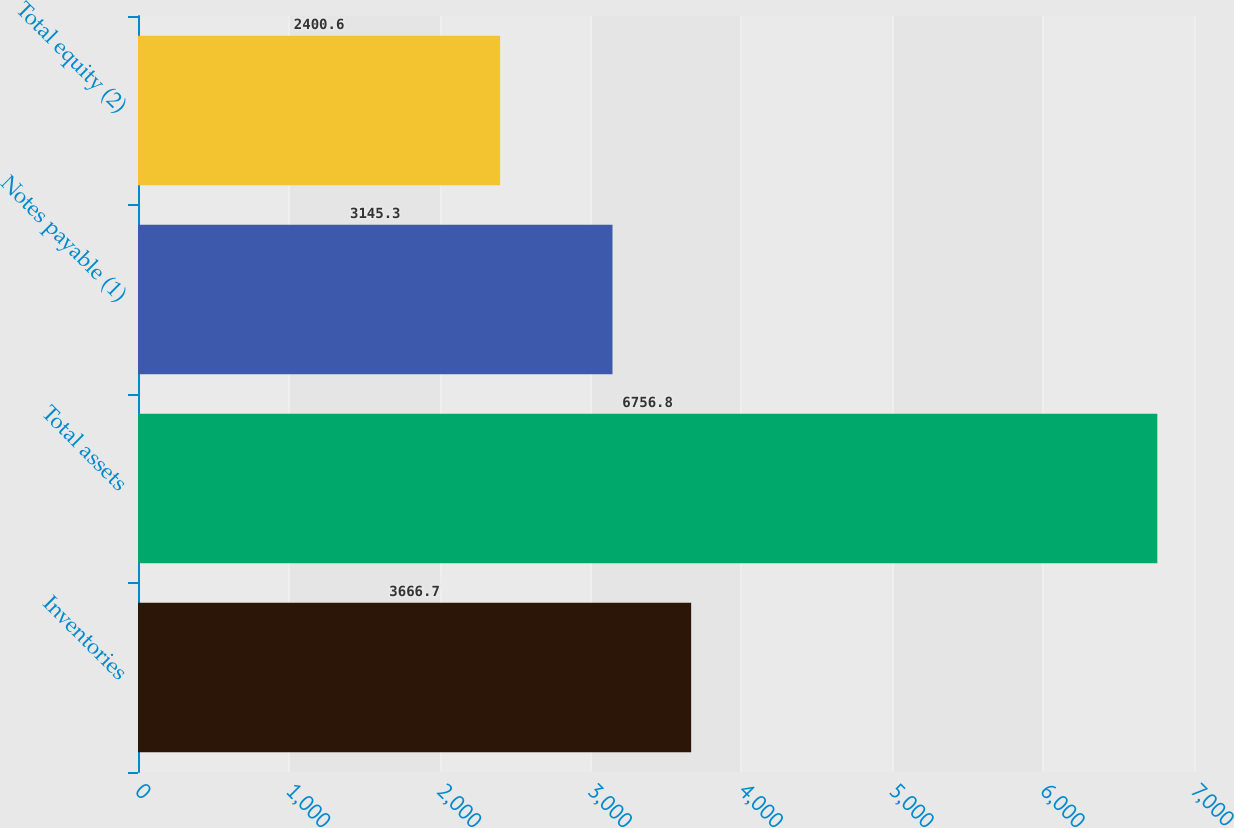Convert chart. <chart><loc_0><loc_0><loc_500><loc_500><bar_chart><fcel>Inventories<fcel>Total assets<fcel>Notes payable (1)<fcel>Total equity (2)<nl><fcel>3666.7<fcel>6756.8<fcel>3145.3<fcel>2400.6<nl></chart> 